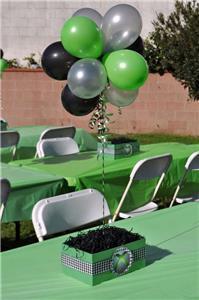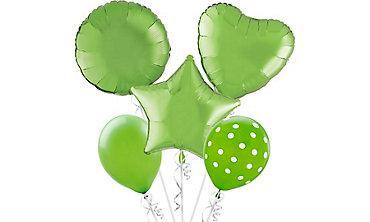The first image is the image on the left, the second image is the image on the right. For the images shown, is this caption "there are plastick baloon holders insteas of ribbons" true? Answer yes or no. No. 